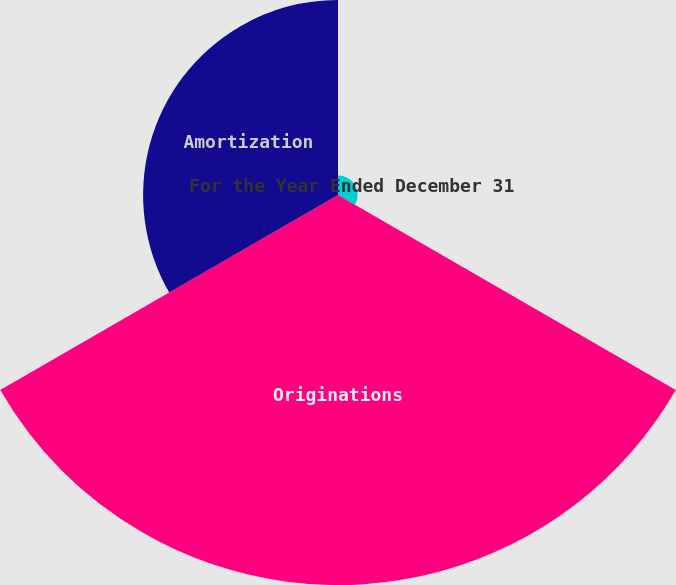Convert chart to OTSL. <chart><loc_0><loc_0><loc_500><loc_500><pie_chart><fcel>For the Year Ended December 31<fcel>Originations<fcel>Amortization<nl><fcel>3.24%<fcel>64.52%<fcel>32.24%<nl></chart> 